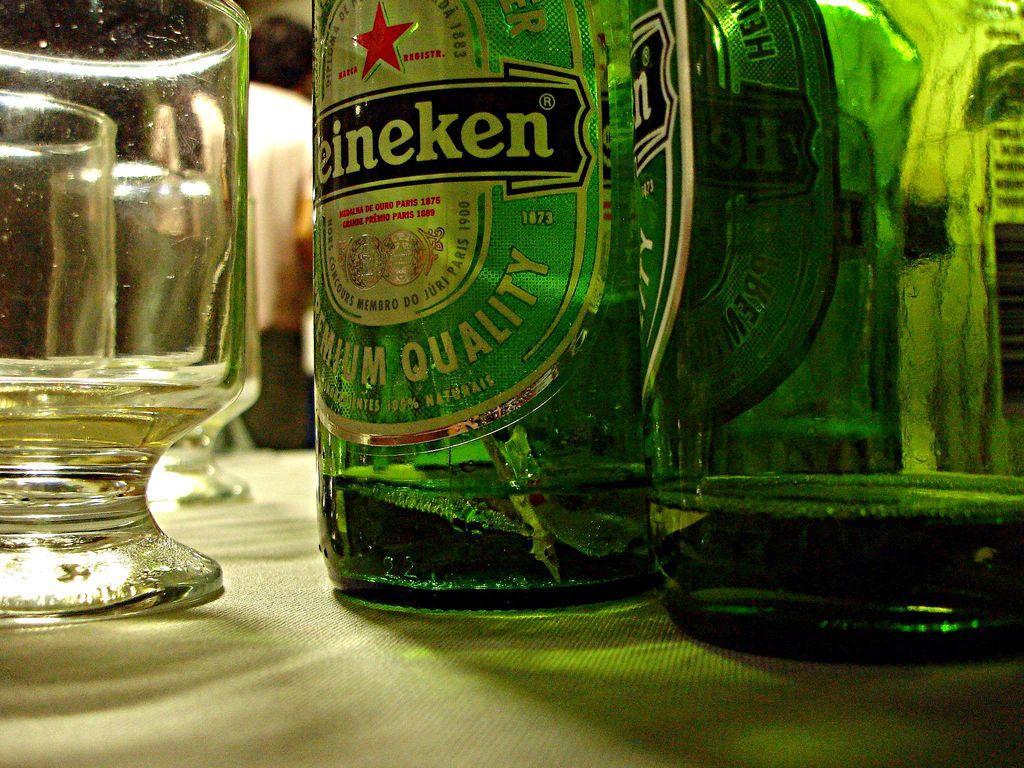What objects related to beverages can be seen in the image? There are bottles and a glass in the image. Where are the bottles and the glass located? The bottles and the glass are on a table. How many goldfish are swimming in the glass in the image? There are no goldfish present in the image; it only features bottles and a glass. What type of riddle can be solved using the information from the image? There is no riddle present in the image, as it only features bottles and a glass on a table. 